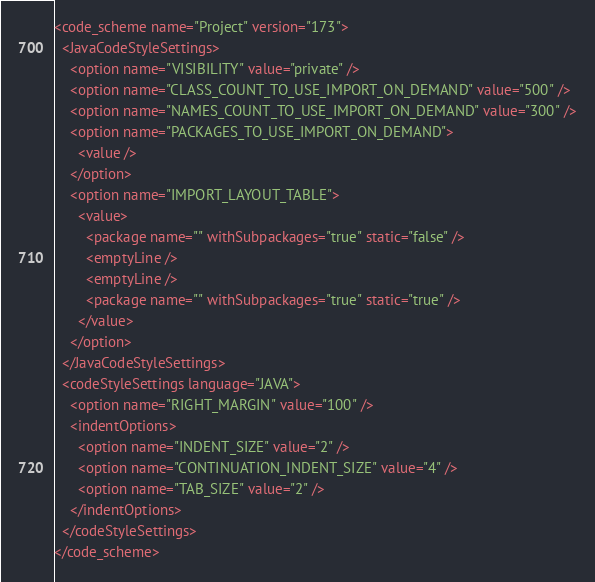Convert code to text. <code><loc_0><loc_0><loc_500><loc_500><_XML_><code_scheme name="Project" version="173">
  <JavaCodeStyleSettings>
    <option name="VISIBILITY" value="private" />
    <option name="CLASS_COUNT_TO_USE_IMPORT_ON_DEMAND" value="500" />
    <option name="NAMES_COUNT_TO_USE_IMPORT_ON_DEMAND" value="300" />
    <option name="PACKAGES_TO_USE_IMPORT_ON_DEMAND">
      <value />
    </option>
    <option name="IMPORT_LAYOUT_TABLE">
      <value>
        <package name="" withSubpackages="true" static="false" />
        <emptyLine />
        <emptyLine />
        <package name="" withSubpackages="true" static="true" />
      </value>
    </option>
  </JavaCodeStyleSettings>
  <codeStyleSettings language="JAVA">
    <option name="RIGHT_MARGIN" value="100" />
    <indentOptions>
      <option name="INDENT_SIZE" value="2" />
      <option name="CONTINUATION_INDENT_SIZE" value="4" />
      <option name="TAB_SIZE" value="2" />
    </indentOptions>
  </codeStyleSettings>
</code_scheme></code> 